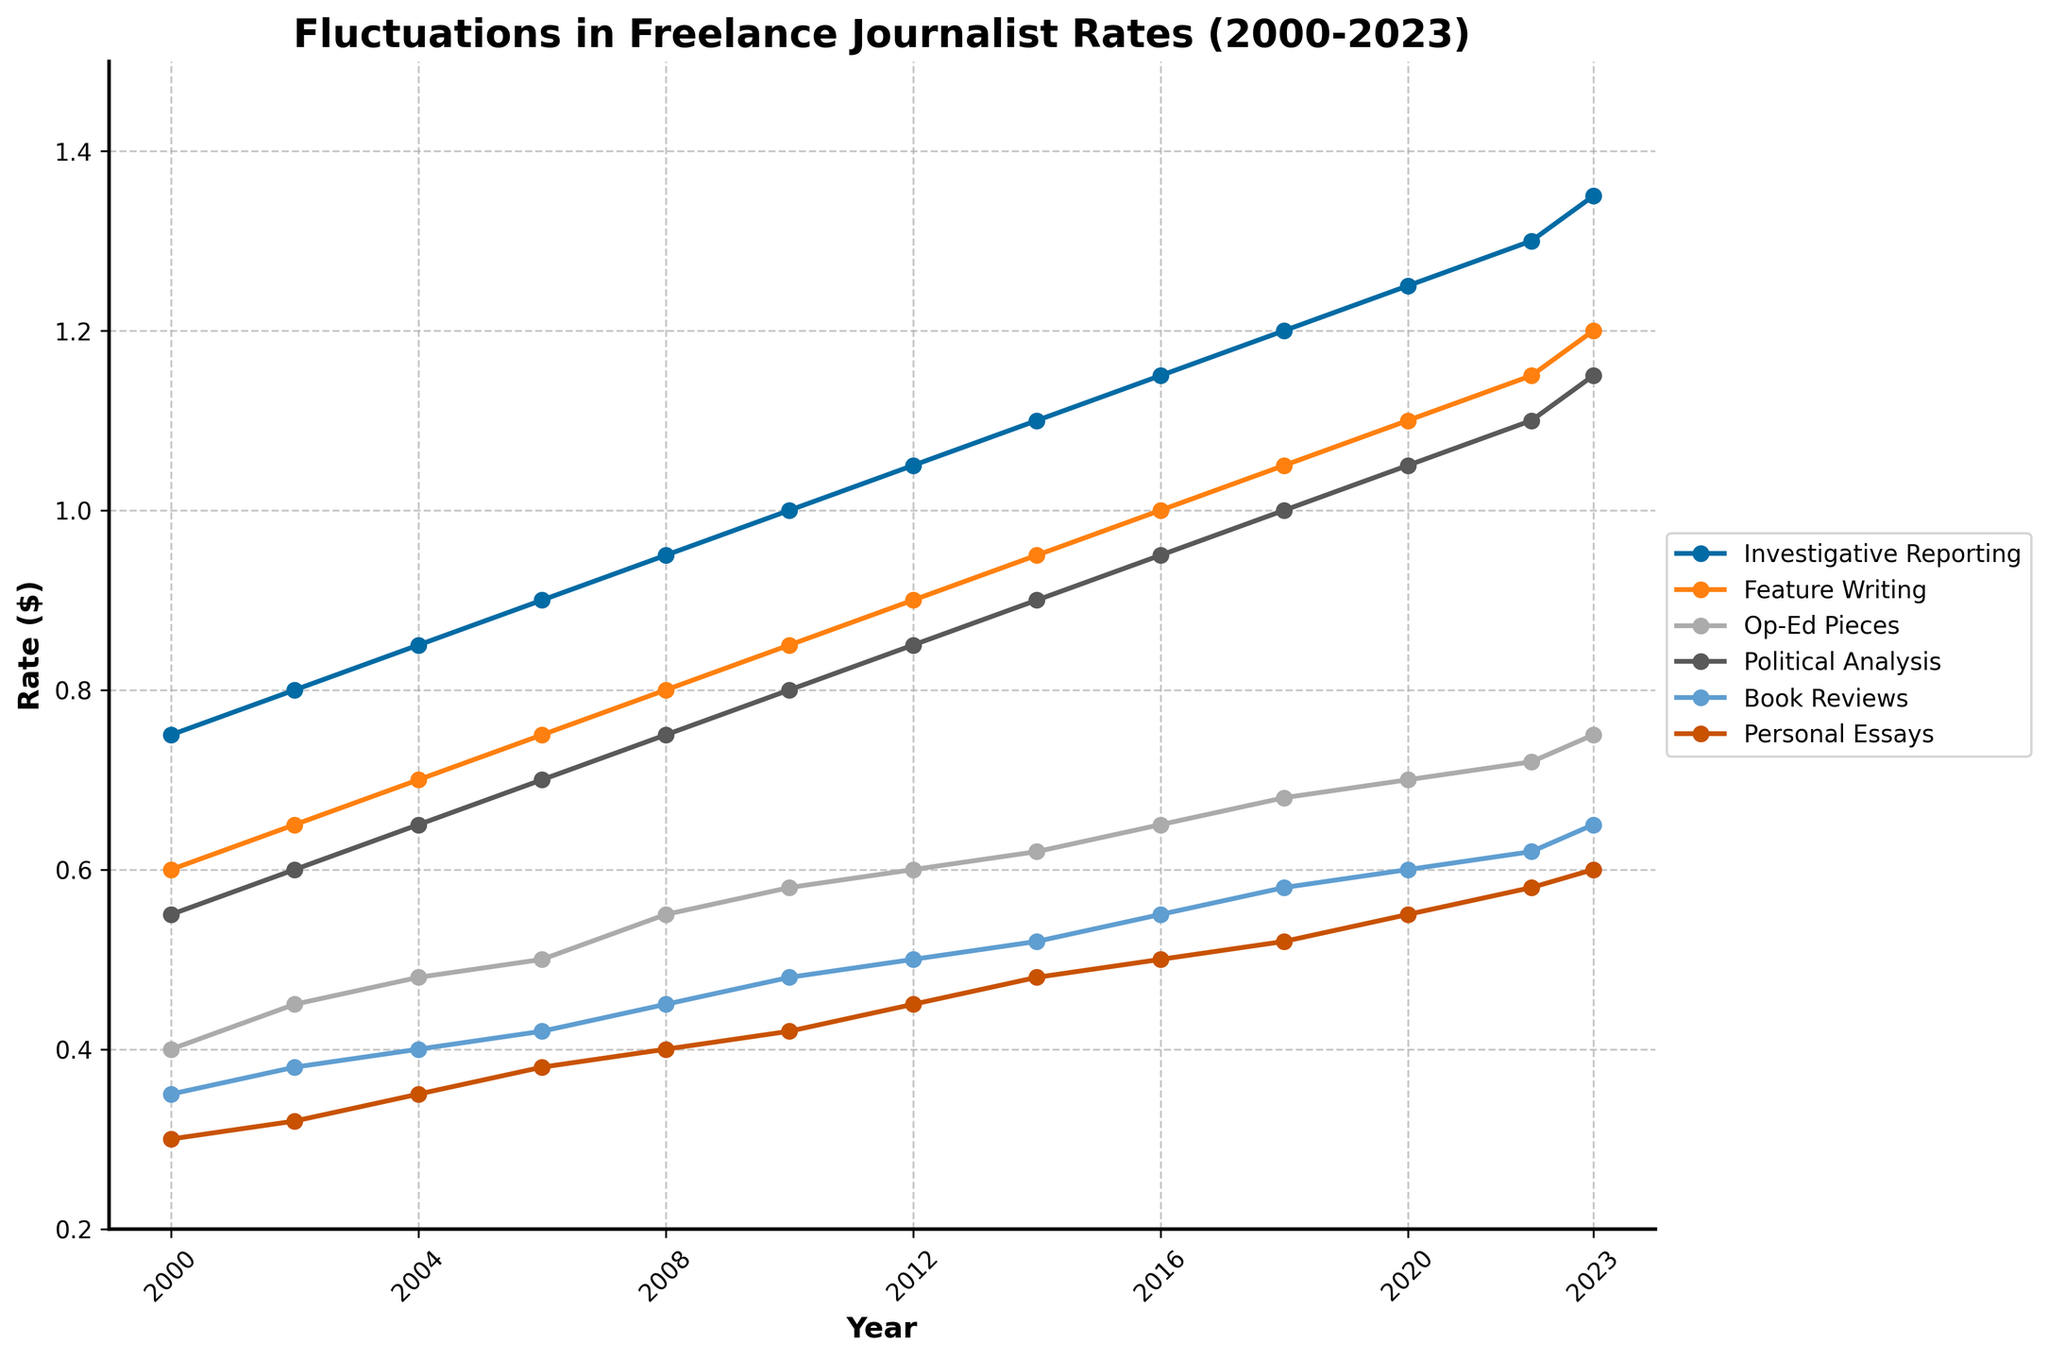Which type of assignment had the highest rate in 2000 and what was the rate? The plot shows the rates for each type of assignment in 2000. Finding the highest rate involves identifying the peak value among the rates for "Investigative Reporting", "Feature Writing", "Op-Ed Pieces", "Political Analysis", "Book Reviews", and "Personal Essays". "Investigative Reporting" had the highest rate at $0.75.
Answer: Investigative Reporting, $0.75 Which year did Feature Writing first surpass the $1.00 rate? Locate the line representing Feature Writing and identify when it crosses the $1.00 rate mark. This occurs in 2016.
Answer: 2016 What is the difference in rates for Political Analysis between 2010 and 2020? Subtract the 2010 rate of $0.80 from the 2020 rate of $1.05. The steps are $1.05 - $0.80 = $0.25.
Answer: $0.25 How much did the rate for Personal Essays increase from 2000 to 2023? Subtract the 2000 rate of $0.30 from the 2023 rate of $0.60. The calculation is $0.60 - $0.30 = $0.30.
Answer: $0.30 Which type of assignment had the smallest rate increase from 2010 to 2023? Calculate the difference between 2023 and 2010 rates for each type: Investigative Reporting ($1.35 - $1.00 = $0.35), Feature Writing ($1.20 - $0.85 = $0.35), Op-Ed Pieces ($0.75 - $0.58 = $0.17), Political Analysis ($1.15 - $0.80 = $0.35), Book Reviews ($0.65 - $0.48 = $0.17), Personal Essays ($0.60 - $0.42 = $0.18). Book Reviews and Op-Ed Pieces have the smallest increase at $0.17.
Answer: Book Reviews and Op-Ed Pieces In which year did Investigative Reporting reach a rate of $1.00? Find the point on the chart where Investigative Reporting hits the $1.00 mark. This occurs in 2010.
Answer: 2010 What is the average rate of Feature Writing in the years 2000, 2010, and 2023? Sum the Feature Writing rates for these years: $0.60 (2000) + $0.85 (2010) + $1.20 (2023) = $2.65, then divide by 3. The calculation is $2.65 / 3 ≈ $0.88.
Answer: ≈ $0.88 Which type of assignment had the steepest rate increase from 2000 to 2023? Analyze the slope of the lines between 2000 and 2023. Calculate the differences for each: Investigative Reporting ($1.35 - $0.75 = $0.60), Feature Writing ($1.20 - $0.60 = $0.60), Op-Ed Pieces ($0.75 - $0.40 = $0.35), Political Analysis ($1.15 - $0.55 = $0.60), Book Reviews ($0.65 - $0.35 = $0.30), Personal Essays ($0.60 - $0.30 = $0.30). Several lines increased by $0.60, but none exceeds this difference.
Answer: Investigative Reporting, Feature Writing, and Political Analysis Compare the rate of Op-Ed Pieces in 2008 and Book Reviews in 2023. Which is higher and by how much? Identify the rates: Op-Ed Pieces in 2008 is $0.55 and Book Reviews in 2023 is $0.65. The difference is $0.65 - $0.55 = $0.10, with Book Reviews being higher.
Answer: Book Reviews by $0.10 